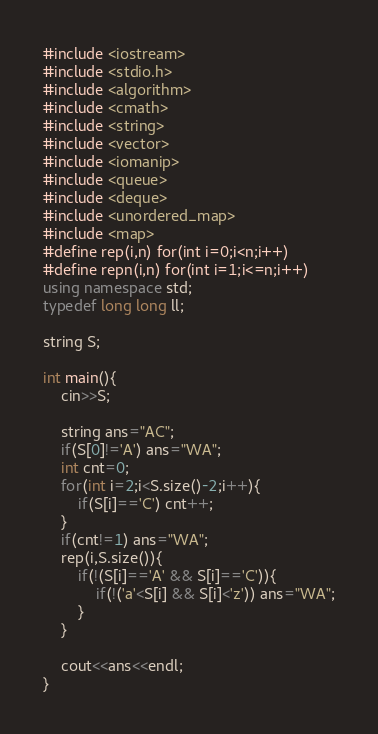<code> <loc_0><loc_0><loc_500><loc_500><_C++_>#include <iostream>
#include <stdio.h>
#include <algorithm>
#include <cmath>
#include <string>
#include <vector>
#include <iomanip>
#include <queue>
#include <deque>
#include <unordered_map>
#include <map>
#define rep(i,n) for(int i=0;i<n;i++)
#define repn(i,n) for(int i=1;i<=n;i++)
using namespace std;
typedef long long ll;

string S;

int main(){
    cin>>S;

    string ans="AC";
    if(S[0]!='A') ans="WA";
    int cnt=0;
    for(int i=2;i<S.size()-2;i++){
        if(S[i]=='C') cnt++;
    }
    if(cnt!=1) ans="WA";
    rep(i,S.size()){
        if(!(S[i]=='A' && S[i]=='C')){
            if(!('a'<S[i] && S[i]<'z')) ans="WA";
        }
    }

    cout<<ans<<endl;
}</code> 